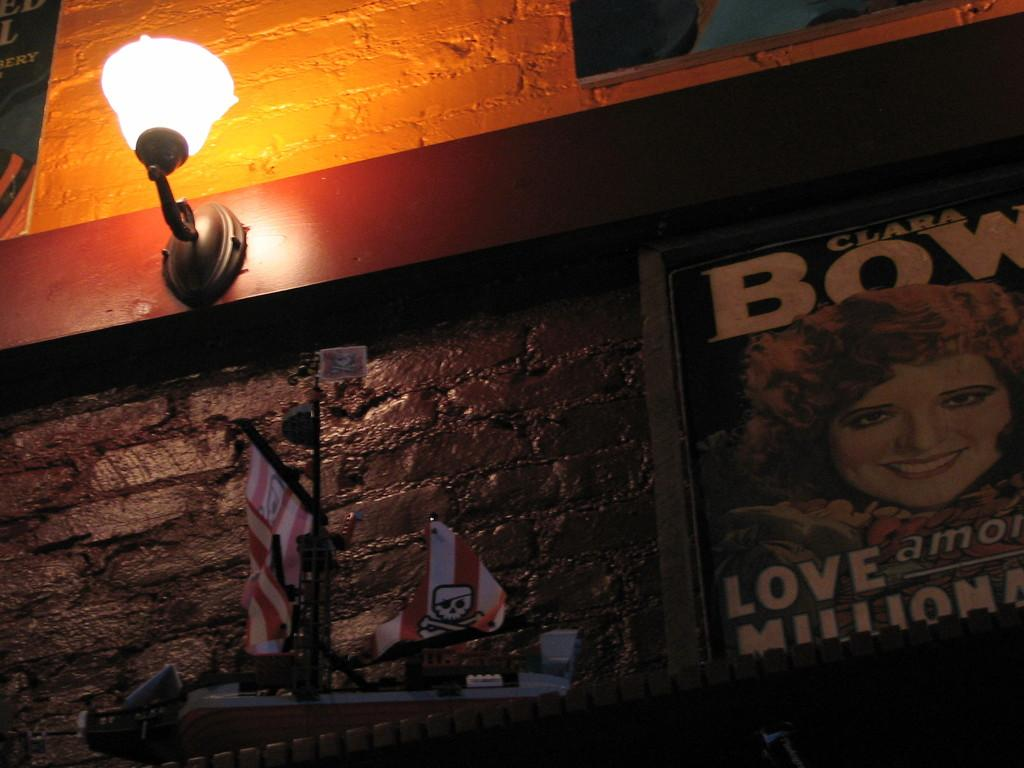What can be seen on the wall in the image? There are posts on the wall in the image. What source of illumination is present in the image? There is a light in the image. What other items can be seen in the image? There are some objects in the image. Where is the tramp located in the image? There is no tramp present in the image. What type of map can be seen in the image? There is no map present in the image. 